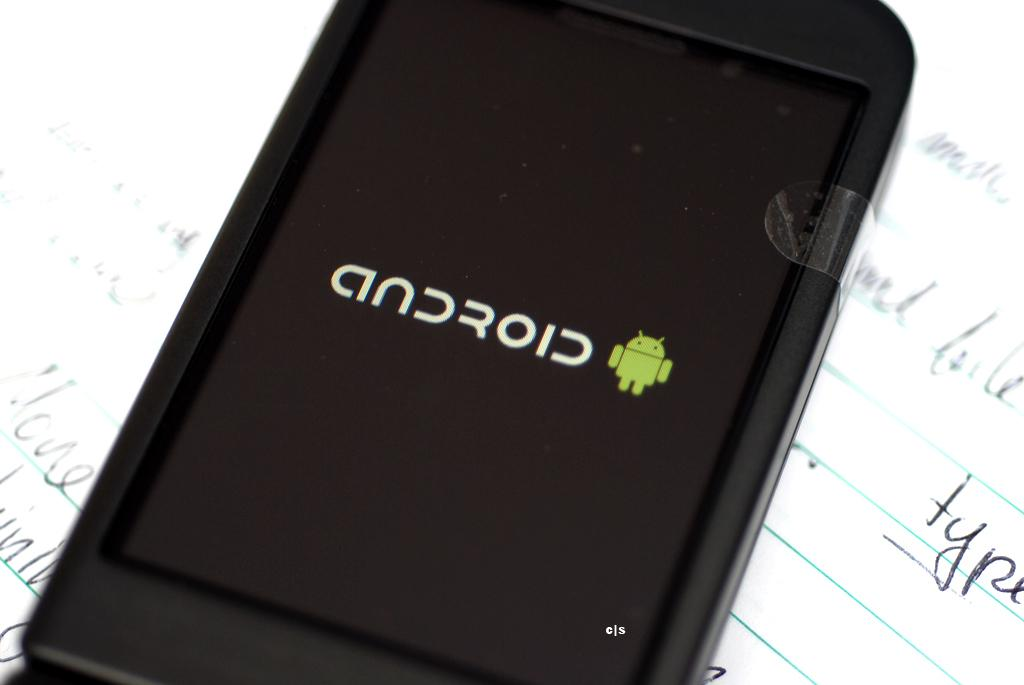<image>
Create a compact narrative representing the image presented. An Android device lying on a sheet of ruled paper with handwriting on it. 